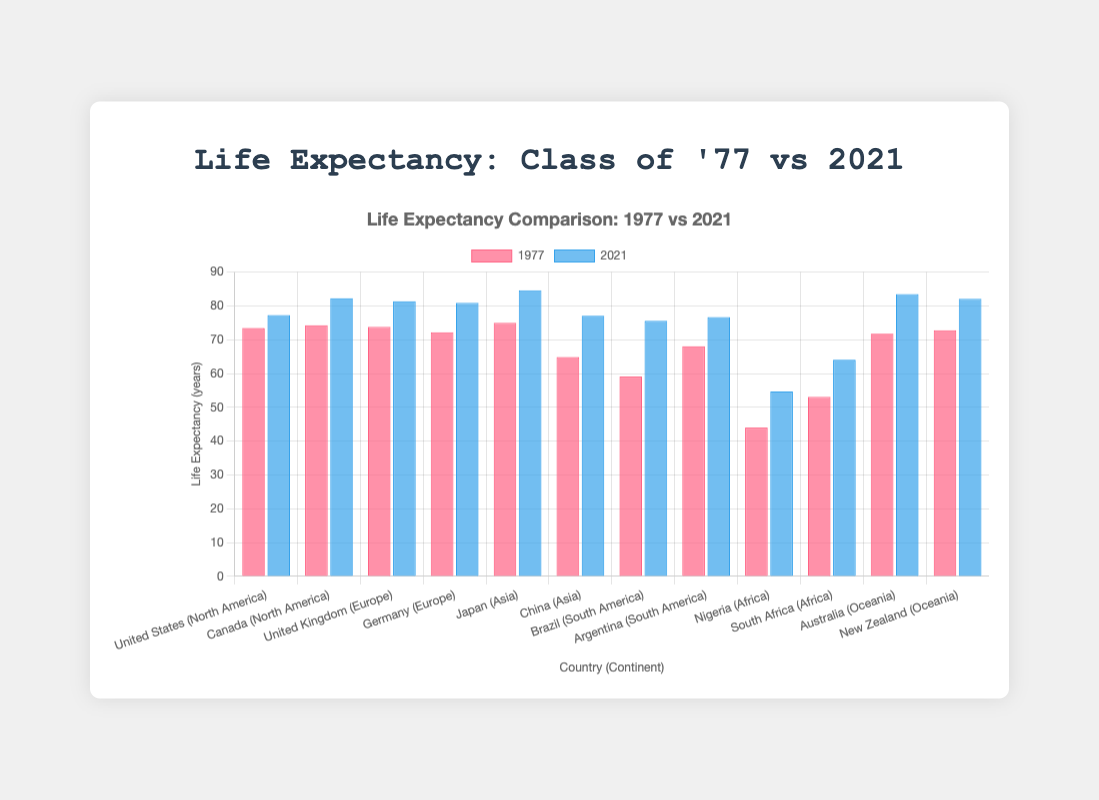How did the life expectancy in Canada change from 1977 to 2021? To find the change, subtract the life expectancy in 1977 from the life expectancy in 2021 for Canada. It is 82.3 - 74.3.
Answer: 8 years Which country in Asia had the highest life expectancy in 2021? Compare the life expectancy values for Japan and China in 2021. Japan's is 84.6 and China's is 77.1. So, Japan has the highest life expectancy.
Answer: Japan What is the difference in life expectancy between Nigeria and South Africa in 1977? Subtract Nigeria's life expectancy in 1977 from South Africa's. It is 53.1 - 44.0.
Answer: 9.1 years Which continent saw the greatest increase in life expectancy from 1977 to 2021? To determine this, find the difference between life expectancy values of countries in each continent for both years and then identify the continent with the highest average increase. For instance, sum the increases for each continent and compare them: North America (3.8, 8.0), Europe (7.6, 8.7), Asia (9.6, 12.2), South America (16.5, 8.6), Africa (10.7, 11.0), Oceania (11.7, 9.3). Sum and average these values per continent, Asia has the greatest average increase.
Answer: Asia How does the life expectancy in the United States in 2021 compare visually to that in 1977? Notice the height of the bars for the United States in both colors. The blue bar (2021) is slightly taller than the red bar (1977), indicating a higher life expectancy in 2021.
Answer: Higher Which country saw the smallest increase in life expectancy from 1977 to 2021? Examine the differences between life expectancy values in 2021 and 1977 for each country and identify the smallest one. United States: 3.8, Canada: 8.0, United Kingdom: 7.6, Germany: 8.7, Japan: 9.6, China: 12.2, Brazil: 16.5, Argentina: 8.6, Nigeria: 10.7, South Africa: 11.0, Australia: 11.7, New Zealand: 9.3. The smallest increase is in the United States.
Answer: United States Whose life expectancy increased more: Germany from 1977 to 2021 or Brazil from 1977 to 2021? Calculate the increase for both countries: Germany 80.9 - 72.2 = 8.7, Brazil 75.6 - 59.1 = 16.5. Brazil's increase is greater.
Answer: Brazil What is the average life expectancy in 2021 for the countries in Africa? Sum the life expectancy values for Nigeria and South Africa in 2021 and divide by the number of countries: (54.7 + 64.1) / 2 = 118.8 / 2.
Answer: 59.4 years How does the life expectancy in Australia in 2021 compare to the life expectancy in Japan in 2021? Compare the life expectancy values for both countries in 2021. Australia: 83.5, Japan: 84.6. Japan's is higher.
Answer: Japan 